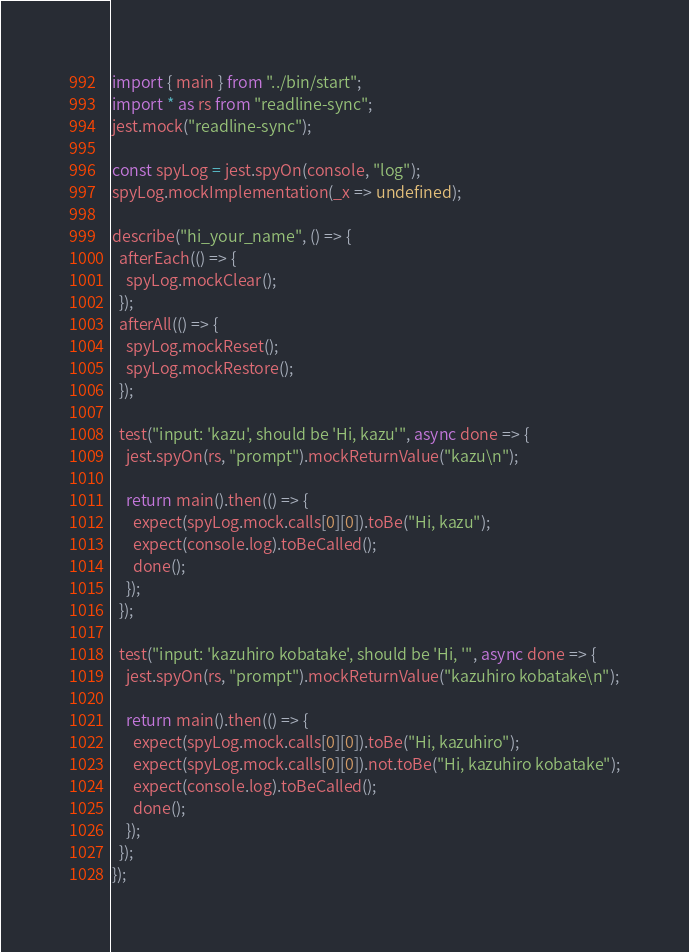Convert code to text. <code><loc_0><loc_0><loc_500><loc_500><_TypeScript_>import { main } from "../bin/start";
import * as rs from "readline-sync";
jest.mock("readline-sync");

const spyLog = jest.spyOn(console, "log");
spyLog.mockImplementation(_x => undefined);

describe("hi_your_name", () => {
  afterEach(() => {
    spyLog.mockClear();
  });
  afterAll(() => {
    spyLog.mockReset();
    spyLog.mockRestore();
  });

  test("input: 'kazu', should be 'Hi, kazu'", async done => {
    jest.spyOn(rs, "prompt").mockReturnValue("kazu\n");

    return main().then(() => {
      expect(spyLog.mock.calls[0][0]).toBe("Hi, kazu");
      expect(console.log).toBeCalled();
      done();
    });
  });

  test("input: 'kazuhiro kobatake', should be 'Hi, '", async done => {
    jest.spyOn(rs, "prompt").mockReturnValue("kazuhiro kobatake\n");

    return main().then(() => {
      expect(spyLog.mock.calls[0][0]).toBe("Hi, kazuhiro");
      expect(spyLog.mock.calls[0][0]).not.toBe("Hi, kazuhiro kobatake");
      expect(console.log).toBeCalled();
      done();
    });
  });
});
</code> 